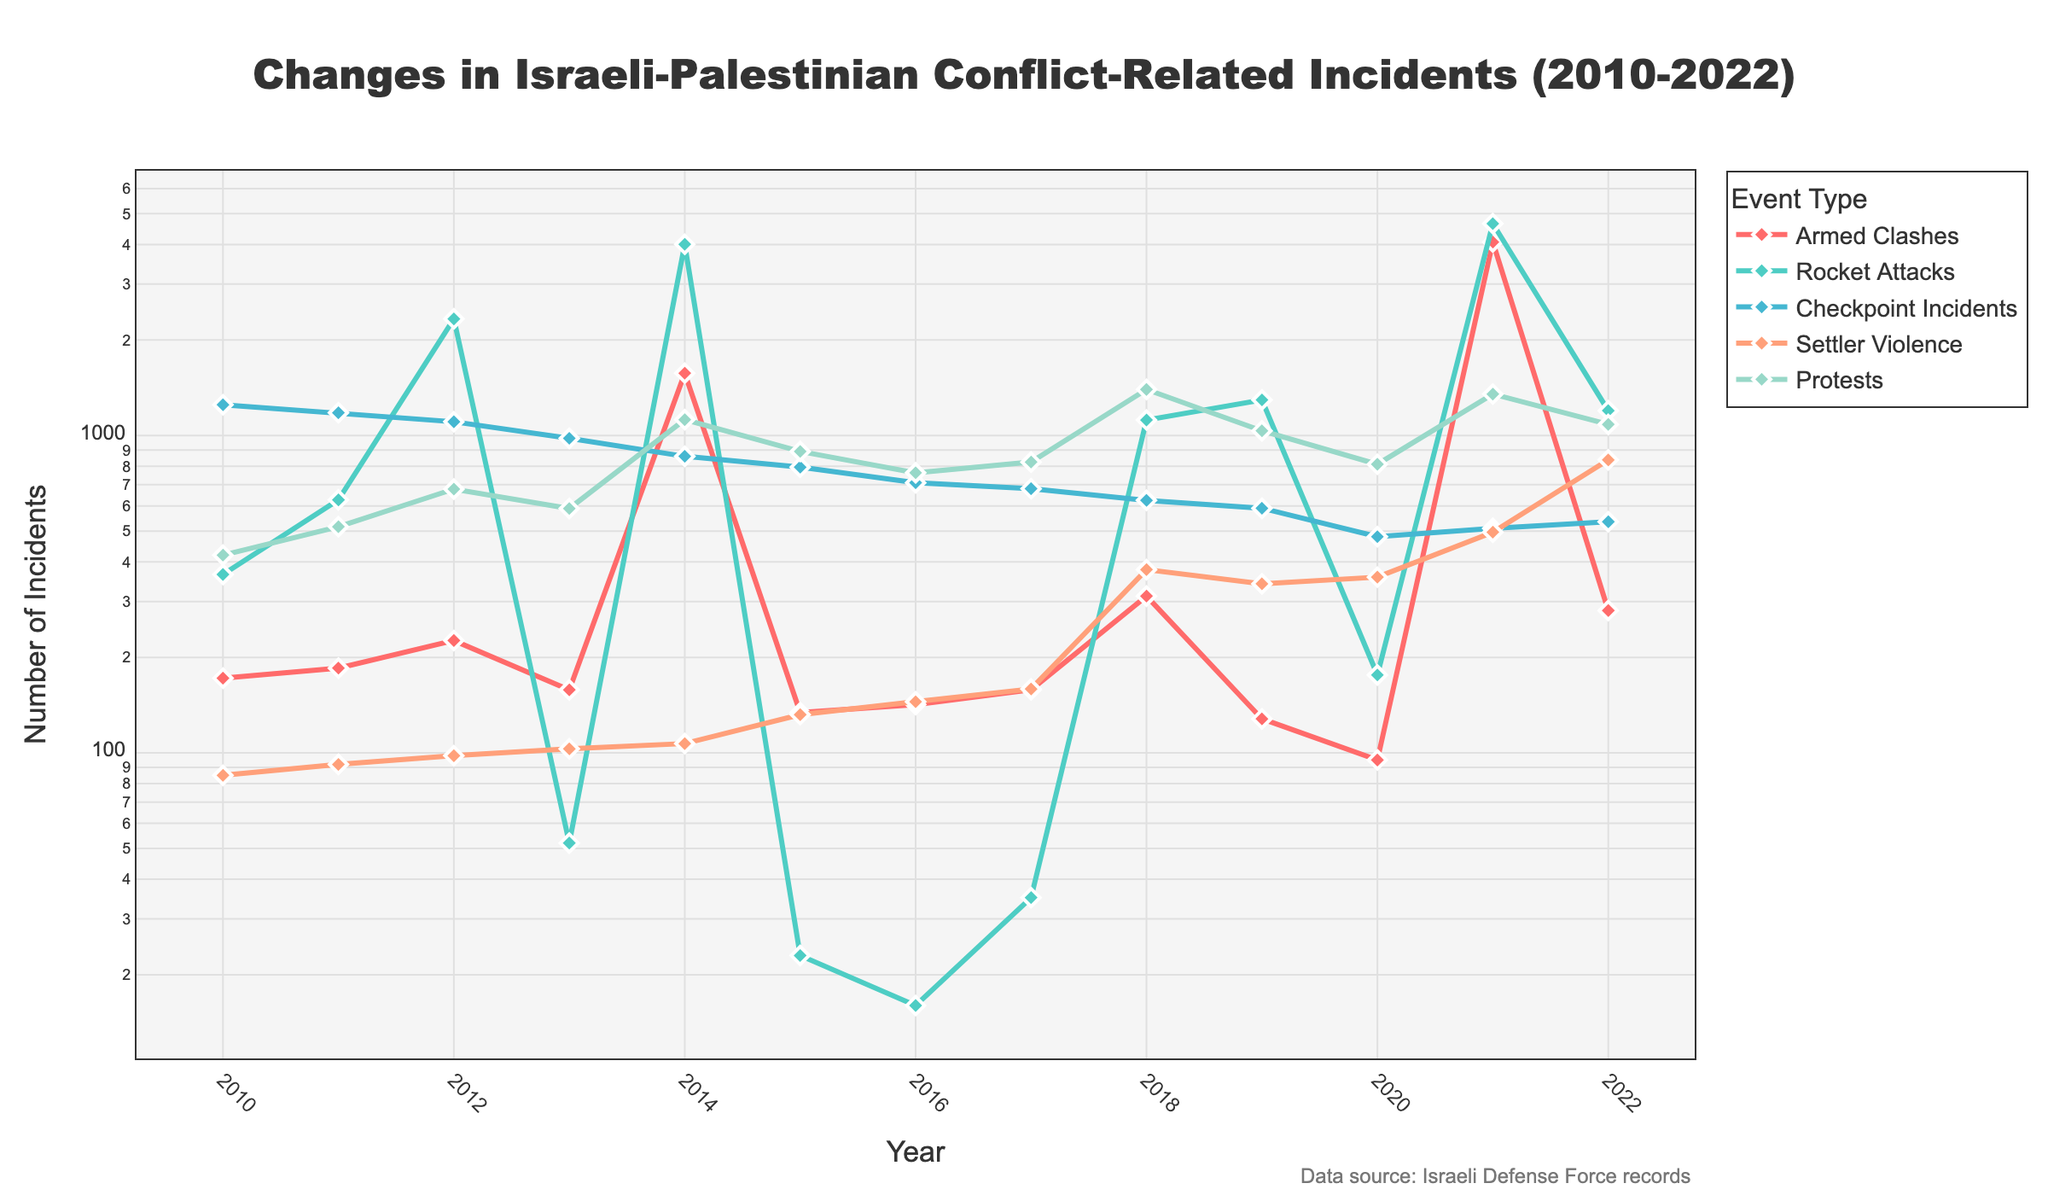Which event type had the highest peak in incidents, and in which year did it occur? The data shows the highest peak for Rocket Attacks with the value reaching its maximum in 2021, as indicated by the highest point in the chart for that category.
Answer: Rocket Attacks in 2021 How did the number of Armed Clashes in 2014 compare to 2010? The number of Armed Clashes in 2014 is dramatically higher than in 2010. Referring to the specific years, Armed Clashes in 2010 were 172, while in 2014 they were 1572.
Answer: Much higher in 2014 What was the overall trend for Checkpoint Incidents from 2010 to 2022? Observing the line for Checkpoint Incidents, we see a general downward trend from 1250 incidents in 2010 to 535 in 2022, with some fluctuations.
Answer: Downward trend Calculate the average number of Protests over the years shown. Sum the number of Protests for all years and divide by the number of years: (420 + 516 + 678 + 589 + 1122 + 891 + 763 + 825 + 1397 + 1035 + 812 + 1351 + 1084) / 13. That results in an average of approximately 870.77.
Answer: Approximately 870.77 Which event type showed a significant increase in 2021 compared to its value in 2020? Comparing the line plots between 2020 and 2021, Rocket Attacks show a significant increase from 176 incidents in 2020 to 4652 incidents in 2021.
Answer: Rocket Attacks Was Settler Violence in 2018 higher, lower, or equal to Settler Violence in 2019? Checking the data points and their corresponding lines, in 2018 Settler Violence was at 378 whereas in 2019 it was 341. This shows that it was higher in 2018.
Answer: Higher in 2018 Compare the visual trends of Protests and Armed Clashes from 2017 to 2022. Both Protests and Armed Clashes generally show increasing trends over this period, though Protests demonstrate a larger increase with more visible peaks. Armed Clashes also show an increase but with less drastic changes compared to Protests.
Answer: Both increased, Protests increased more What is the difference between the number of Rocket Attacks in 2022 and 2013? The data shows Rocket Attacks in 2022 were 1198 and in 2013 were 52. The difference is 1198 - 52 = 1146.
Answer: 1146 Which year had the lowest number of Armed Clashes? Visually, the lowest point in the Armed Clashes line is in 2020 with 95 incidents.
Answer: 2020 